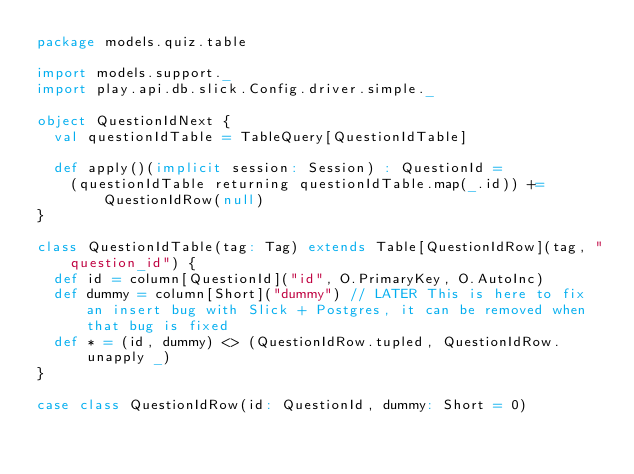<code> <loc_0><loc_0><loc_500><loc_500><_Scala_>package models.quiz.table

import models.support._
import play.api.db.slick.Config.driver.simple._

object QuestionIdNext {
	val questionIdTable = TableQuery[QuestionIdTable]

	def apply()(implicit session: Session) : QuestionId =
		(questionIdTable returning questionIdTable.map(_.id)) += QuestionIdRow(null)
}

class QuestionIdTable(tag: Tag) extends Table[QuestionIdRow](tag, "question_id") {
	def id = column[QuestionId]("id", O.PrimaryKey, O.AutoInc)
	def dummy = column[Short]("dummy") // LATER This is here to fix an insert bug with Slick + Postgres, it can be removed when that bug is fixed
	def * = (id, dummy) <> (QuestionIdRow.tupled, QuestionIdRow.unapply _)
}

case class QuestionIdRow(id: QuestionId, dummy: Short = 0)</code> 